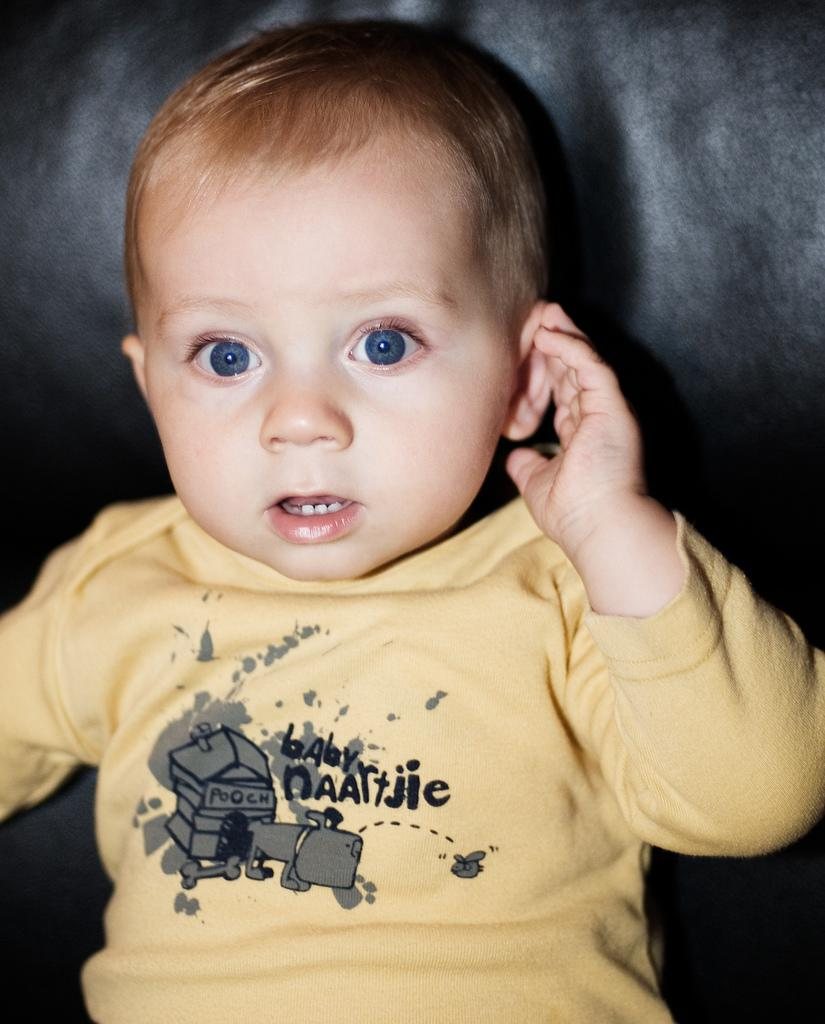Who is the main subject in the image? There is a boy in the image. What can be seen in the background of the image? The background of the image is black in color. Is there a dog playing in the sleet in the image? There is no dog or sleet present in the image; it features a boy with a black background. 